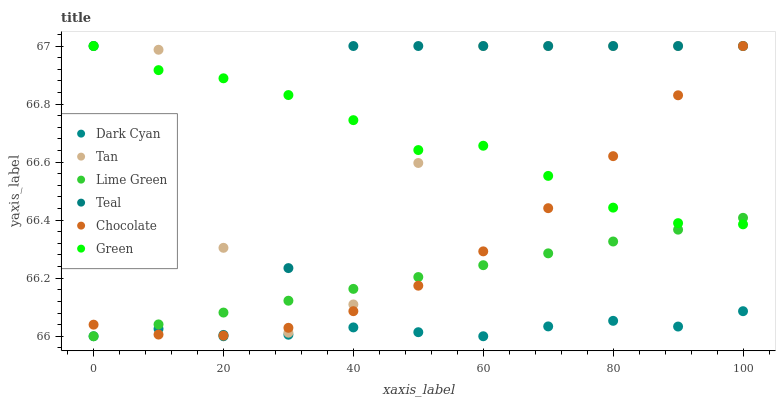Does Dark Cyan have the minimum area under the curve?
Answer yes or no. Yes. Does Teal have the maximum area under the curve?
Answer yes or no. Yes. Does Green have the minimum area under the curve?
Answer yes or no. No. Does Green have the maximum area under the curve?
Answer yes or no. No. Is Lime Green the smoothest?
Answer yes or no. Yes. Is Tan the roughest?
Answer yes or no. Yes. Is Green the smoothest?
Answer yes or no. No. Is Green the roughest?
Answer yes or no. No. Does Dark Cyan have the lowest value?
Answer yes or no. Yes. Does Teal have the lowest value?
Answer yes or no. No. Does Tan have the highest value?
Answer yes or no. Yes. Does Dark Cyan have the highest value?
Answer yes or no. No. Is Dark Cyan less than Green?
Answer yes or no. Yes. Is Tan greater than Dark Cyan?
Answer yes or no. Yes. Does Chocolate intersect Green?
Answer yes or no. Yes. Is Chocolate less than Green?
Answer yes or no. No. Is Chocolate greater than Green?
Answer yes or no. No. Does Dark Cyan intersect Green?
Answer yes or no. No. 